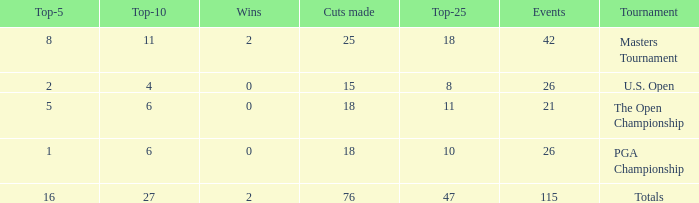What are the largest cuts made when the events are less than 21? None. 